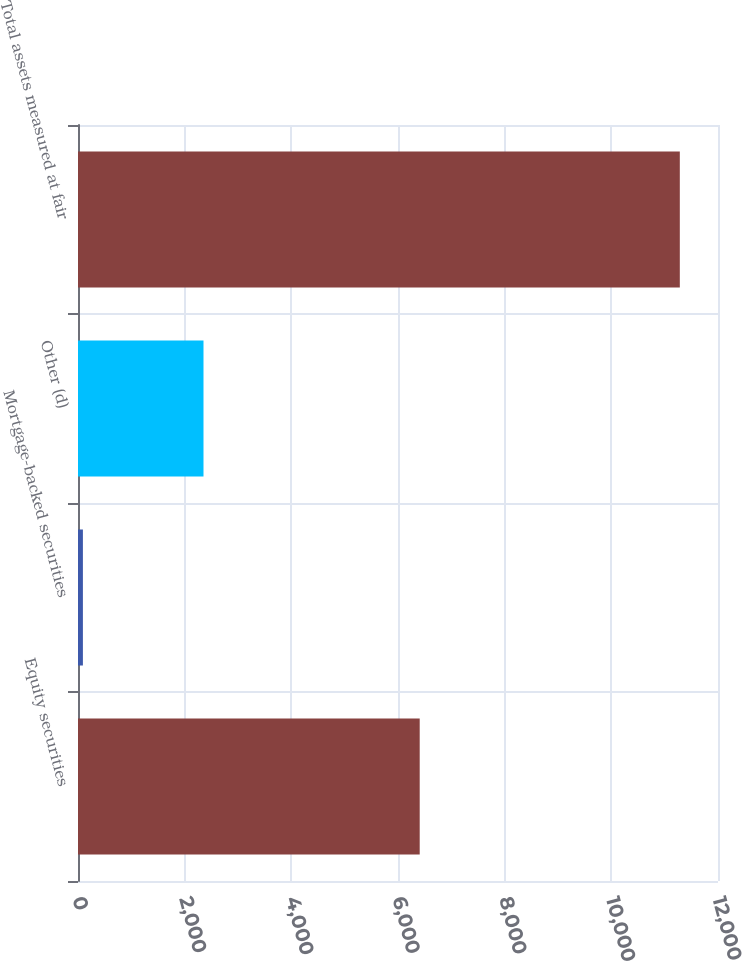<chart> <loc_0><loc_0><loc_500><loc_500><bar_chart><fcel>Equity securities<fcel>Mortgage-backed securities<fcel>Other (d)<fcel>Total assets measured at fair<nl><fcel>6407<fcel>92<fcel>2353<fcel>11284<nl></chart> 